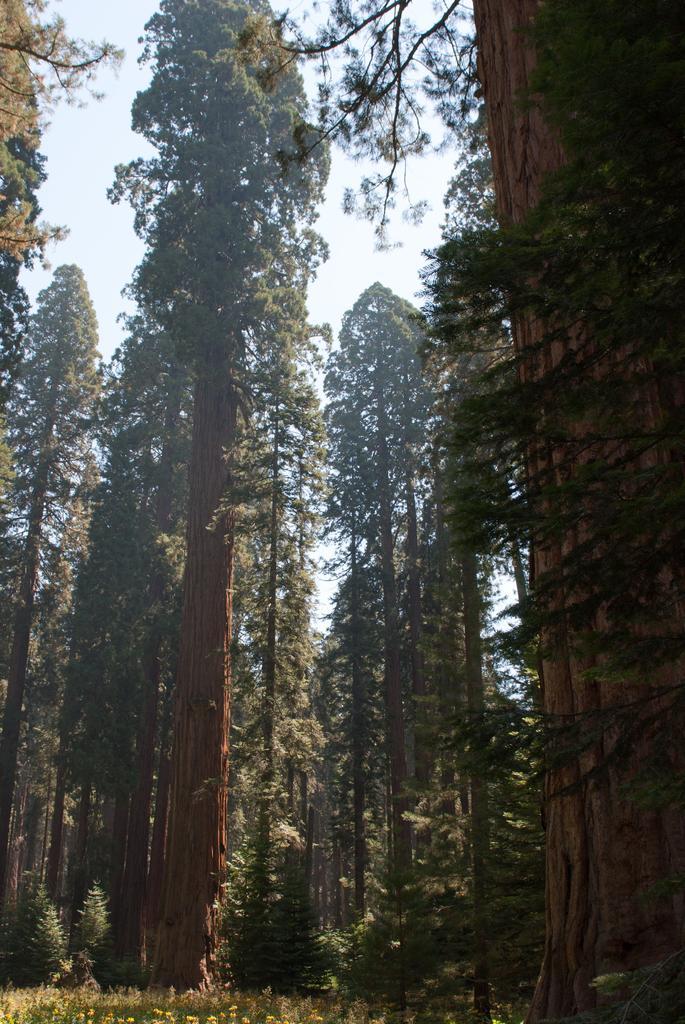Please provide a concise description of this image. In this picture we can see trees, flowers and in the background we can see the sky. 